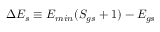Convert formula to latex. <formula><loc_0><loc_0><loc_500><loc_500>\Delta E _ { s } \equiv E _ { \min } ( S _ { g s } + 1 ) - E _ { g s }</formula> 